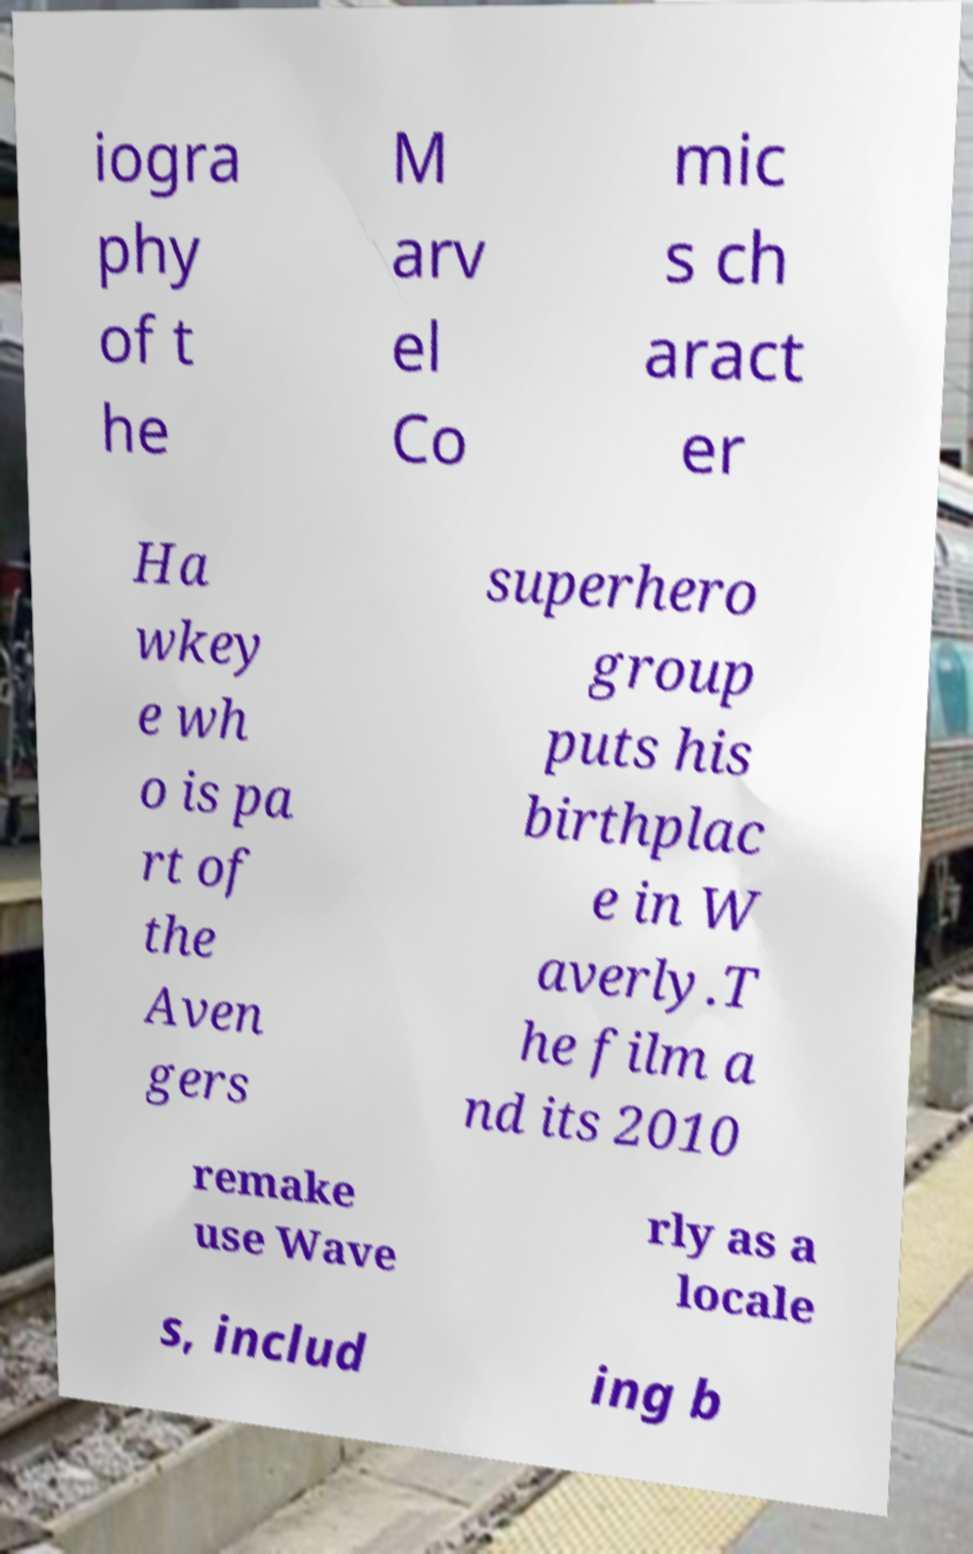Please read and relay the text visible in this image. What does it say? iogra phy of t he M arv el Co mic s ch aract er Ha wkey e wh o is pa rt of the Aven gers superhero group puts his birthplac e in W averly.T he film a nd its 2010 remake use Wave rly as a locale s, includ ing b 